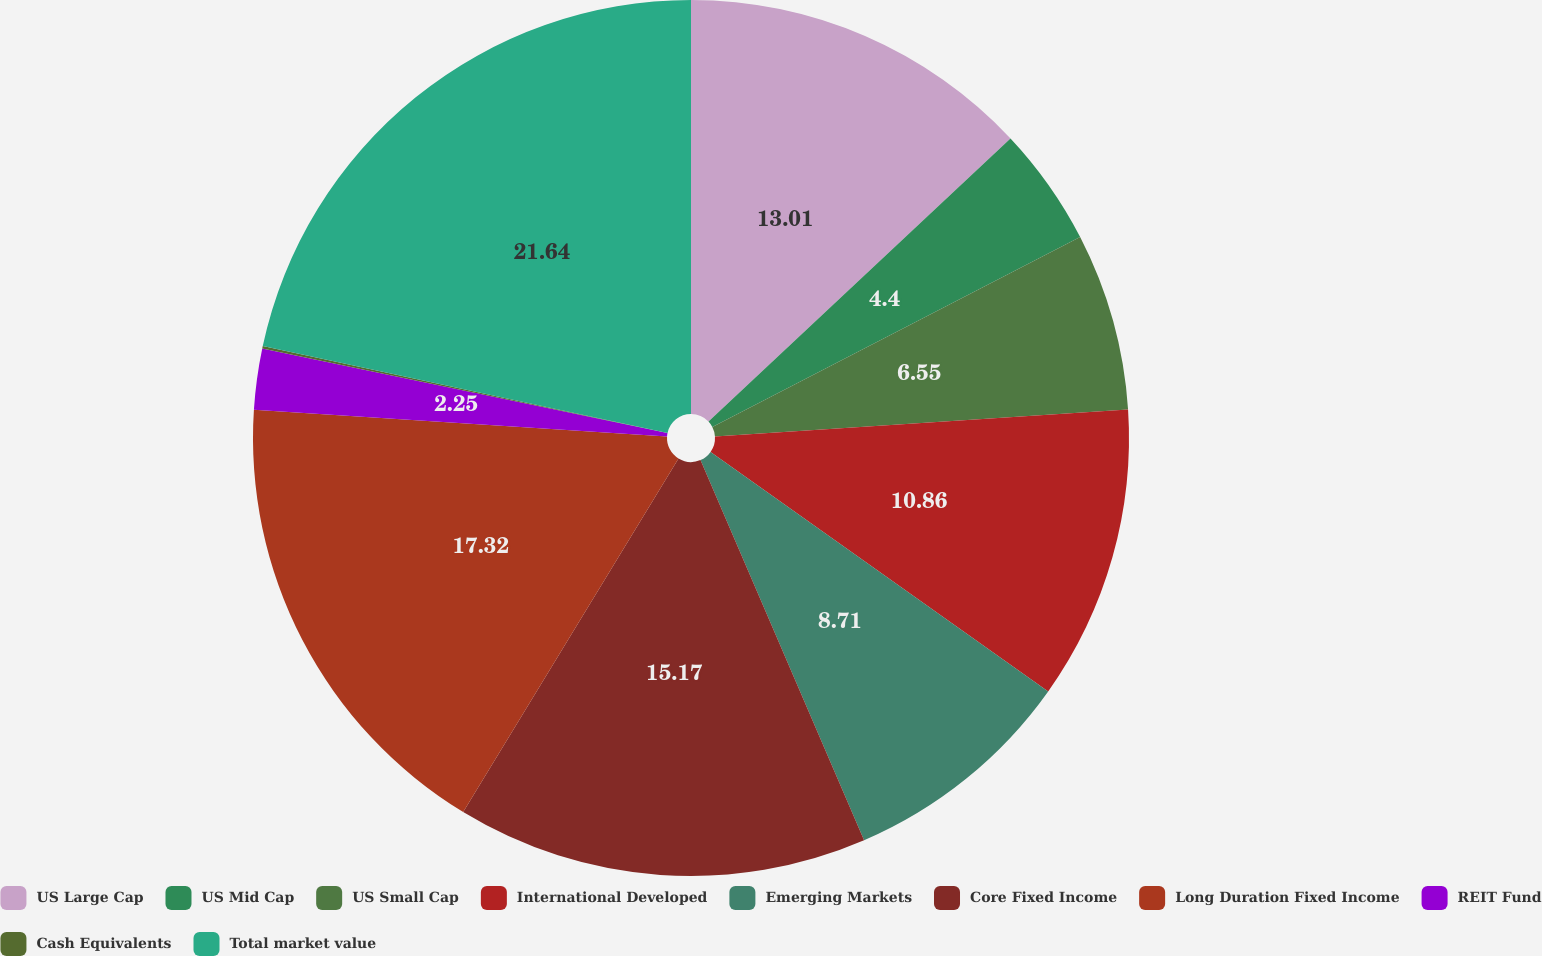Convert chart to OTSL. <chart><loc_0><loc_0><loc_500><loc_500><pie_chart><fcel>US Large Cap<fcel>US Mid Cap<fcel>US Small Cap<fcel>International Developed<fcel>Emerging Markets<fcel>Core Fixed Income<fcel>Long Duration Fixed Income<fcel>REIT Fund<fcel>Cash Equivalents<fcel>Total market value<nl><fcel>13.01%<fcel>4.4%<fcel>6.55%<fcel>10.86%<fcel>8.71%<fcel>15.17%<fcel>17.32%<fcel>2.25%<fcel>0.09%<fcel>21.63%<nl></chart> 